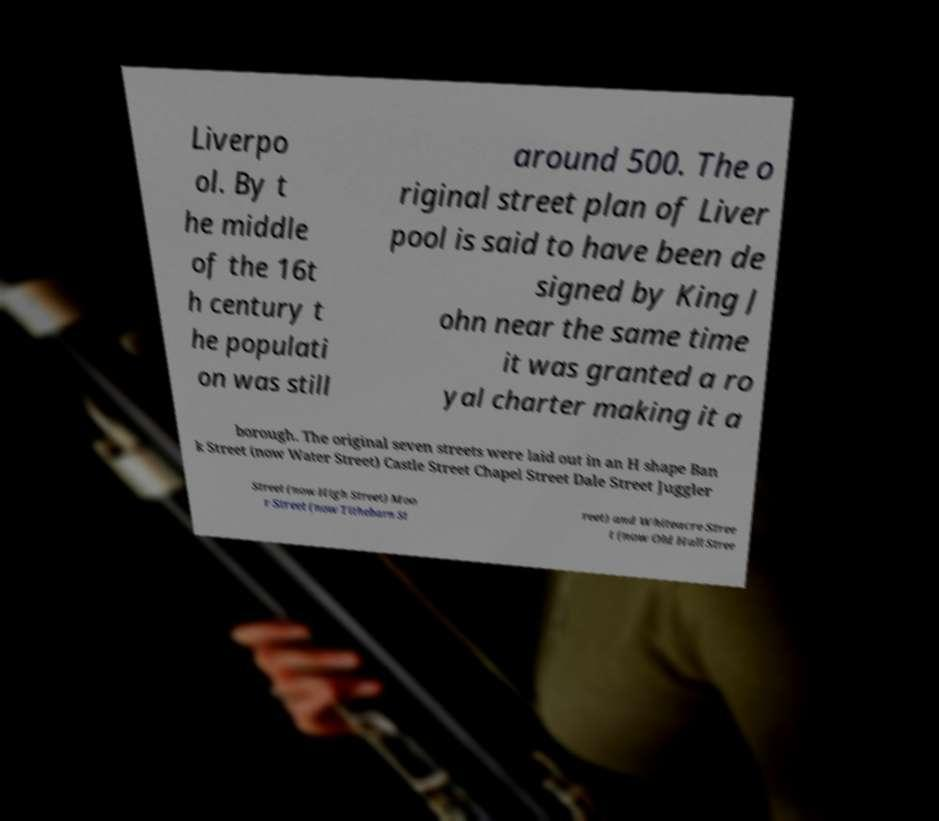Please identify and transcribe the text found in this image. Liverpo ol. By t he middle of the 16t h century t he populati on was still around 500. The o riginal street plan of Liver pool is said to have been de signed by King J ohn near the same time it was granted a ro yal charter making it a borough. The original seven streets were laid out in an H shape Ban k Street (now Water Street) Castle Street Chapel Street Dale Street Juggler Street (now High Street) Moo r Street (now Tithebarn St reet) and Whiteacre Stree t (now Old Hall Stree 